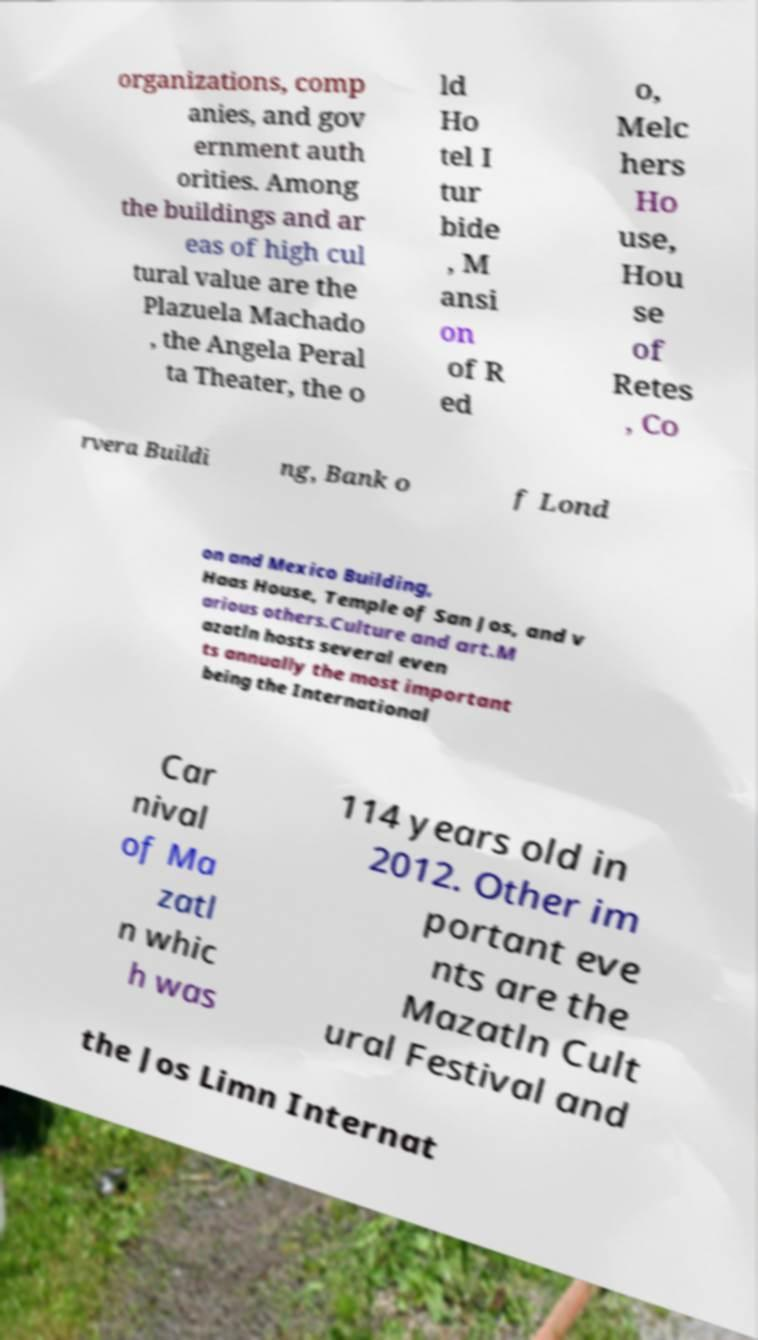Please identify and transcribe the text found in this image. organizations, comp anies, and gov ernment auth orities. Among the buildings and ar eas of high cul tural value are the Plazuela Machado , the Angela Peral ta Theater, the o ld Ho tel I tur bide , M ansi on of R ed o, Melc hers Ho use, Hou se of Retes , Co rvera Buildi ng, Bank o f Lond on and Mexico Building, Haas House, Temple of San Jos, and v arious others.Culture and art.M azatln hosts several even ts annually the most important being the International Car nival of Ma zatl n whic h was 114 years old in 2012. Other im portant eve nts are the Mazatln Cult ural Festival and the Jos Limn Internat 